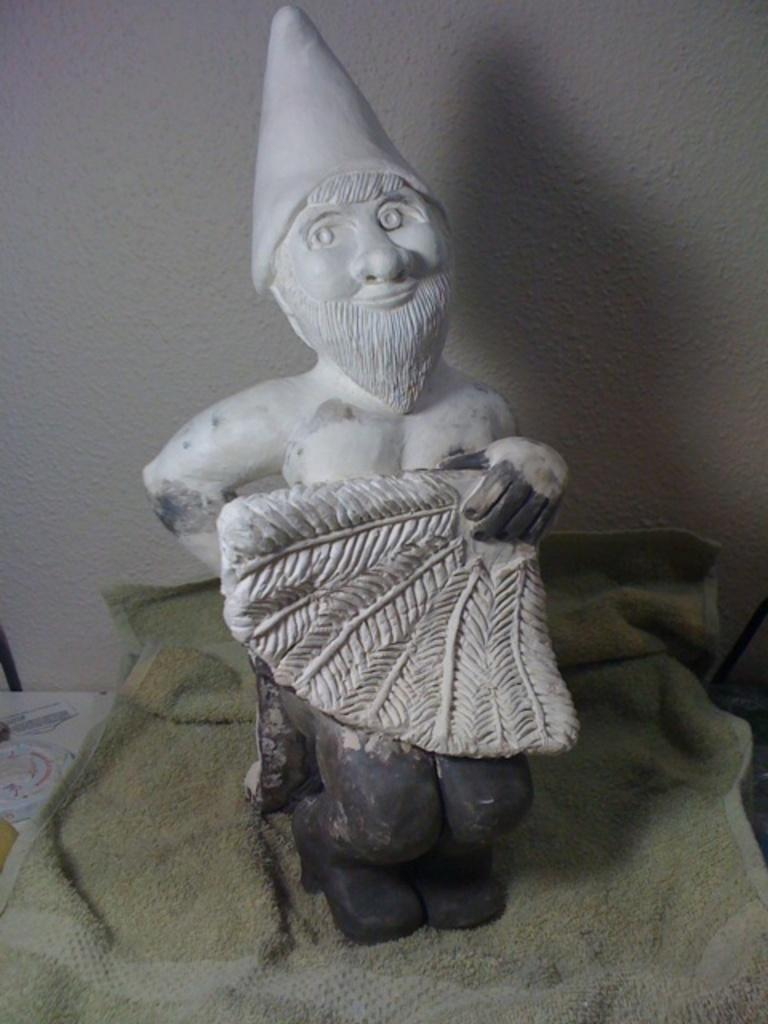Where was the image taken? The image was taken indoors. What can be seen in the background of the image? There is a wall in the background of the image. What is located at the bottom of the image? There is a table at the bottom of the image. What is placed on the table in the image? There is a napkin and a clay doll on the table. How many apples are on the table in the image? There are no apples present in the image. What is the increase in the number of chairs in the image? There is no mention of chairs in the image, so it is not possible to determine any increase in their number. 